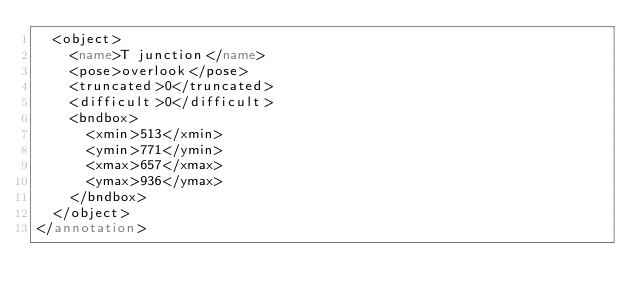<code> <loc_0><loc_0><loc_500><loc_500><_XML_>	<object>
		<name>T junction</name>
		<pose>overlook</pose>
		<truncated>0</truncated>
		<difficult>0</difficult>
		<bndbox>
			<xmin>513</xmin>
			<ymin>771</ymin>
			<xmax>657</xmax>
			<ymax>936</ymax>
		</bndbox>
	</object>
</annotation>
</code> 